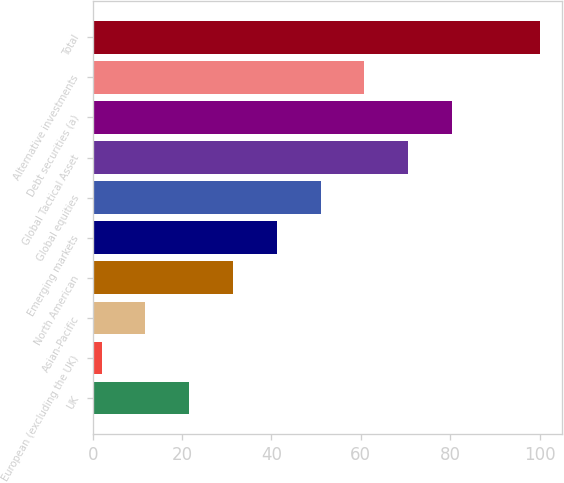Convert chart to OTSL. <chart><loc_0><loc_0><loc_500><loc_500><bar_chart><fcel>UK<fcel>European (excluding the UK)<fcel>Asian-Pacific<fcel>North American<fcel>Emerging markets<fcel>Global equities<fcel>Global Tactical Asset<fcel>Debt securities (a)<fcel>Alternative investments<fcel>Total<nl><fcel>21.6<fcel>2<fcel>11.8<fcel>31.4<fcel>41.2<fcel>51<fcel>70.6<fcel>80.4<fcel>60.8<fcel>100<nl></chart> 